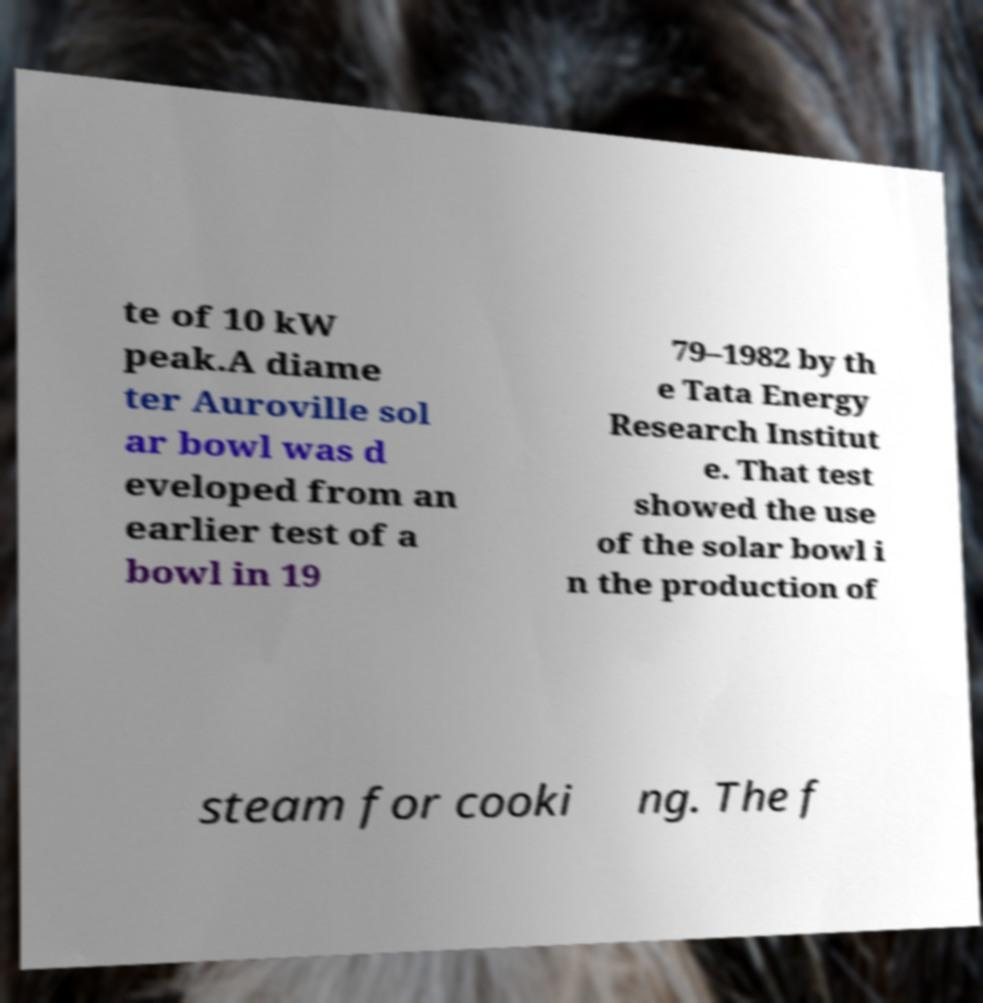Could you assist in decoding the text presented in this image and type it out clearly? te of 10 kW peak.A diame ter Auroville sol ar bowl was d eveloped from an earlier test of a bowl in 19 79–1982 by th e Tata Energy Research Institut e. That test showed the use of the solar bowl i n the production of steam for cooki ng. The f 